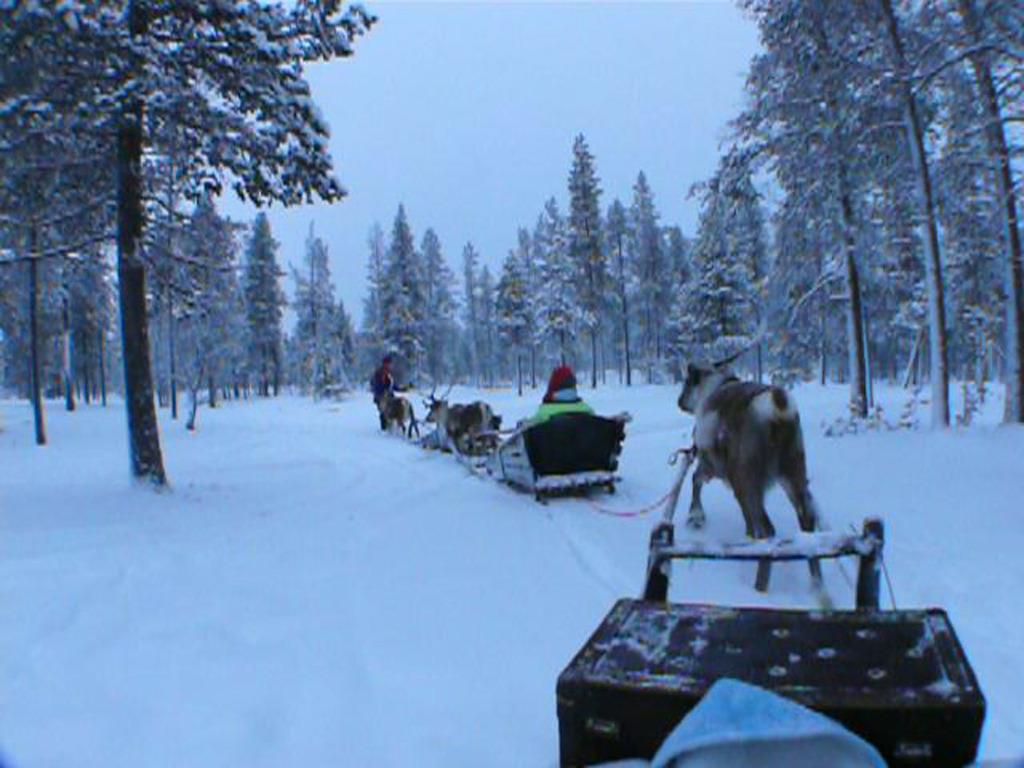What type of vegetation is visible in the image? There are trees on the snow in the image. What are the people doing in the image? The people are riding yak carts in the image. What type of current can be seen flowing through the trees in the image? There is no current visible in the image; it is a snowy and the trees are on the snow. What type of produce is being harvested by the people riding yak carts in the image? There is no produce being harvested in the image; the people are riding yak carts, not engaging in any agricultural activity. 